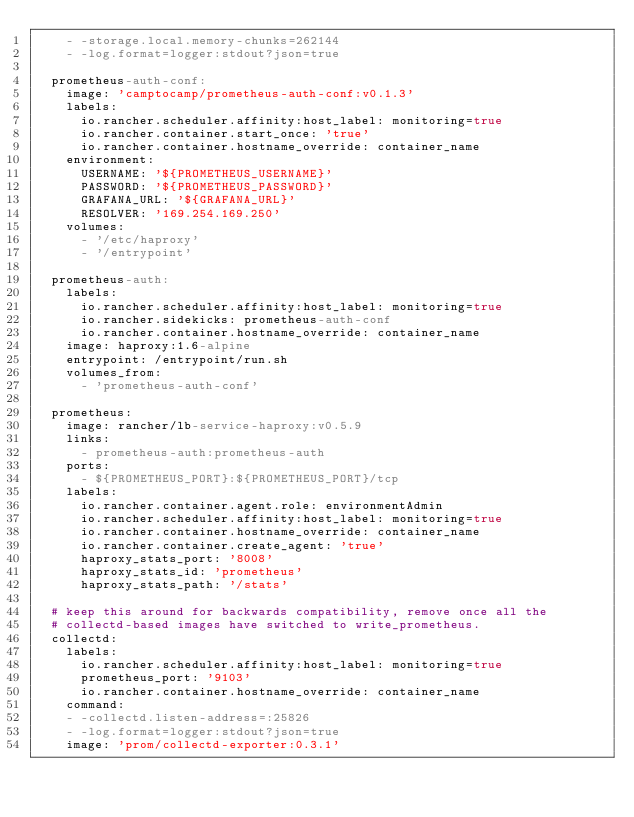Convert code to text. <code><loc_0><loc_0><loc_500><loc_500><_YAML_>    - -storage.local.memory-chunks=262144
    - -log.format=logger:stdout?json=true
  
  prometheus-auth-conf:
    image: 'camptocamp/prometheus-auth-conf:v0.1.3'
    labels:
      io.rancher.scheduler.affinity:host_label: monitoring=true
      io.rancher.container.start_once: 'true'
      io.rancher.container.hostname_override: container_name
    environment:
      USERNAME: '${PROMETHEUS_USERNAME}'
      PASSWORD: '${PROMETHEUS_PASSWORD}'
      GRAFANA_URL: '${GRAFANA_URL}'
      RESOLVER: '169.254.169.250'
    volumes:
      - '/etc/haproxy'
      - '/entrypoint'
  
  prometheus-auth:
    labels:
      io.rancher.scheduler.affinity:host_label: monitoring=true
      io.rancher.sidekicks: prometheus-auth-conf
      io.rancher.container.hostname_override: container_name
    image: haproxy:1.6-alpine
    entrypoint: /entrypoint/run.sh
    volumes_from:
      - 'prometheus-auth-conf'

  prometheus:
    image: rancher/lb-service-haproxy:v0.5.9
    links:
      - prometheus-auth:prometheus-auth
    ports:
      - ${PROMETHEUS_PORT}:${PROMETHEUS_PORT}/tcp
    labels:
      io.rancher.container.agent.role: environmentAdmin
      io.rancher.scheduler.affinity:host_label: monitoring=true
      io.rancher.container.hostname_override: container_name  		
      io.rancher.container.create_agent: 'true'
      haproxy_stats_port: '8008'
      haproxy_stats_id: 'prometheus'
      haproxy_stats_path: '/stats'
  
  # keep this around for backwards compatibility, remove once all the
  # collectd-based images have switched to write_prometheus.
  collectd:
    labels:
      io.rancher.scheduler.affinity:host_label: monitoring=true
      prometheus_port: '9103'
      io.rancher.container.hostname_override: container_name
    command:
    - -collectd.listen-address=:25826
    - -log.format=logger:stdout?json=true
    image: 'prom/collectd-exporter:0.3.1'
  
</code> 